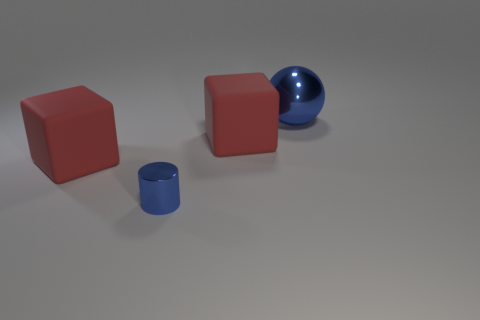Is there any other thing that has the same size as the blue cylinder?
Your answer should be compact. No. There is a big block that is behind the red thing that is to the left of the blue metal object on the left side of the large ball; what is its color?
Make the answer very short. Red. How many cubes are there?
Offer a terse response. 2. How many tiny things are green metal objects or red objects?
Make the answer very short. 0. What material is the blue thing that is behind the big red rubber object that is to the left of the metal cylinder made of?
Provide a succinct answer. Metal. Does the ball have the same size as the blue cylinder?
Your response must be concise. No. What number of things are either big objects on the left side of the large metallic sphere or blue objects?
Your answer should be very brief. 4. There is a blue metal thing behind the shiny thing that is left of the blue metal ball; what is its shape?
Offer a terse response. Sphere. There is a sphere; is it the same size as the red rubber thing right of the small metal object?
Offer a terse response. Yes. What is the material of the small blue cylinder that is left of the big blue thing?
Your response must be concise. Metal. 